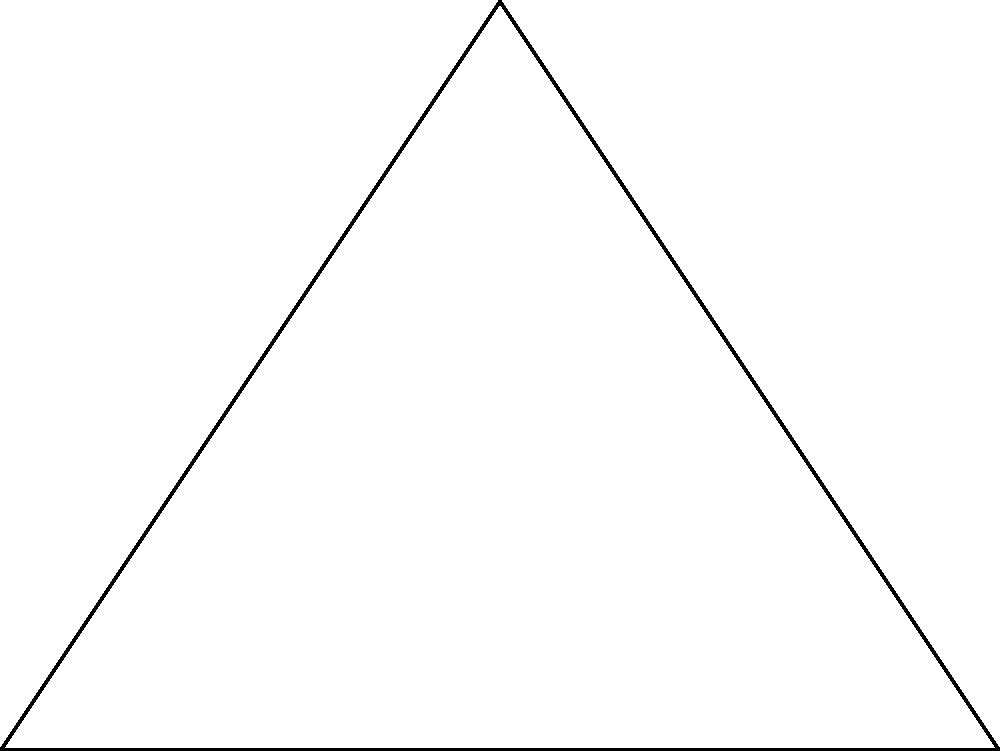In a voting district analysis, three polling stations form a triangle ABC as shown. The distance between stations B and C is 5 km, and the distance between A and C is 3 km. The angle at B (α) is 90°. Using the law of sines, calculate the distance between polling stations A and B to the nearest tenth of a kilometer. How might this information be relevant to assessing the fairness of voting district boundaries? To solve this problem, we'll use the law of sines and the properties of right triangles. Here's a step-by-step approach:

1) In a right triangle, we know that one angle is 90°. The law of sines states:

   $$\frac{a}{\sin A} = \frac{b}{\sin B} = \frac{c}{\sin C}$$

   where a, b, and c are the lengths of the sides opposite to angles A, B, and C respectively.

2) We know that:
   - The angle at B (α) is 90°
   - BC = 5 km
   - AC = 3 km
   - We need to find AB

3) In a right triangle, sin 90° = 1. So we can write:

   $$\frac{AB}{\sin C} = \frac{5}{1}$$

4) We can find sin C using the Pythagorean theorem:

   $$\sin C = \frac{3}{5}$$

5) Substituting this into our equation:

   $$\frac{AB}{\frac{3}{5}} = 5$$

6) Solving for AB:

   $$AB = 5 \cdot \frac{3}{5} = 3$$

7) Therefore, the distance between A and B is 3 km.

This information is relevant to assessing the fairness of voting district boundaries because:

1) It helps in understanding the geographical distribution of polling stations.
2) It can be used to evaluate accessibility for voters in different parts of the district.
3) Uneven distances between polling stations could indicate gerrymandering or unfair district design.
4) This data can be used in conjunction with population density information to ensure equitable representation.
Answer: 3 km 